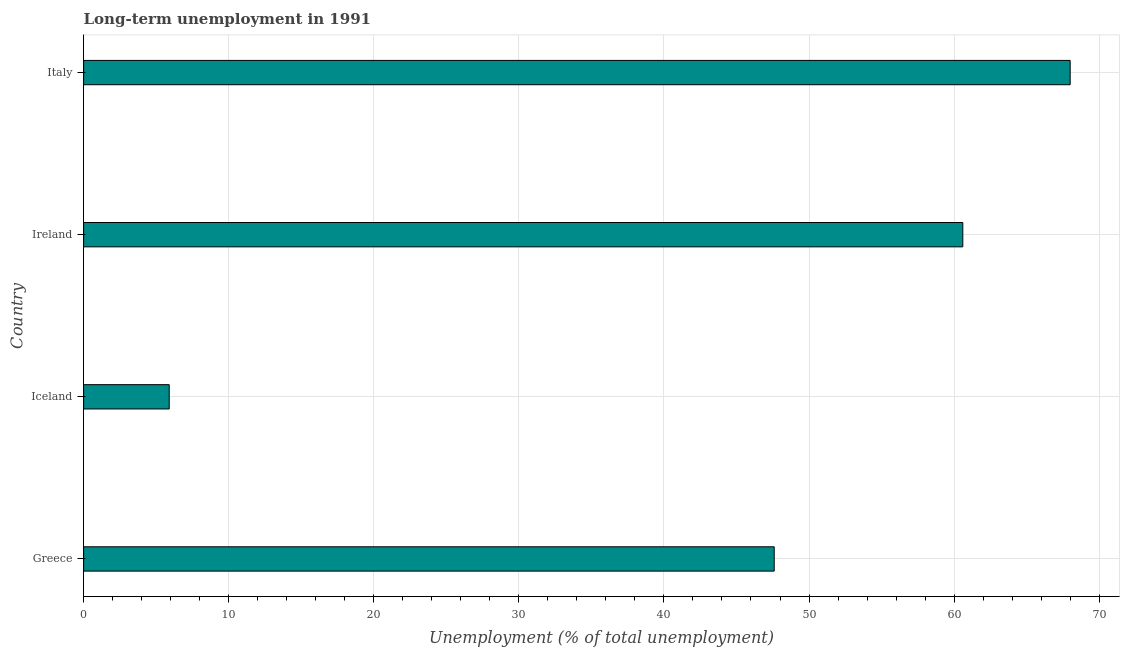Does the graph contain any zero values?
Provide a succinct answer. No. Does the graph contain grids?
Make the answer very short. Yes. What is the title of the graph?
Your response must be concise. Long-term unemployment in 1991. What is the label or title of the X-axis?
Your response must be concise. Unemployment (% of total unemployment). What is the label or title of the Y-axis?
Offer a terse response. Country. What is the long-term unemployment in Ireland?
Your response must be concise. 60.6. Across all countries, what is the minimum long-term unemployment?
Ensure brevity in your answer.  5.9. In which country was the long-term unemployment maximum?
Offer a terse response. Italy. In which country was the long-term unemployment minimum?
Your answer should be very brief. Iceland. What is the sum of the long-term unemployment?
Give a very brief answer. 182.1. What is the difference between the long-term unemployment in Iceland and Ireland?
Make the answer very short. -54.7. What is the average long-term unemployment per country?
Provide a succinct answer. 45.52. What is the median long-term unemployment?
Make the answer very short. 54.1. What is the ratio of the long-term unemployment in Iceland to that in Italy?
Your response must be concise. 0.09. Is the difference between the long-term unemployment in Iceland and Italy greater than the difference between any two countries?
Keep it short and to the point. Yes. What is the difference between the highest and the lowest long-term unemployment?
Your answer should be very brief. 62.1. In how many countries, is the long-term unemployment greater than the average long-term unemployment taken over all countries?
Your answer should be compact. 3. How many bars are there?
Provide a succinct answer. 4. How many countries are there in the graph?
Your answer should be compact. 4. What is the difference between two consecutive major ticks on the X-axis?
Provide a succinct answer. 10. What is the Unemployment (% of total unemployment) of Greece?
Provide a short and direct response. 47.6. What is the Unemployment (% of total unemployment) in Iceland?
Your answer should be very brief. 5.9. What is the Unemployment (% of total unemployment) in Ireland?
Offer a terse response. 60.6. What is the difference between the Unemployment (% of total unemployment) in Greece and Iceland?
Your response must be concise. 41.7. What is the difference between the Unemployment (% of total unemployment) in Greece and Italy?
Keep it short and to the point. -20.4. What is the difference between the Unemployment (% of total unemployment) in Iceland and Ireland?
Offer a very short reply. -54.7. What is the difference between the Unemployment (% of total unemployment) in Iceland and Italy?
Keep it short and to the point. -62.1. What is the ratio of the Unemployment (% of total unemployment) in Greece to that in Iceland?
Your answer should be very brief. 8.07. What is the ratio of the Unemployment (% of total unemployment) in Greece to that in Ireland?
Offer a terse response. 0.79. What is the ratio of the Unemployment (% of total unemployment) in Iceland to that in Ireland?
Give a very brief answer. 0.1. What is the ratio of the Unemployment (% of total unemployment) in Iceland to that in Italy?
Provide a succinct answer. 0.09. What is the ratio of the Unemployment (% of total unemployment) in Ireland to that in Italy?
Your answer should be compact. 0.89. 